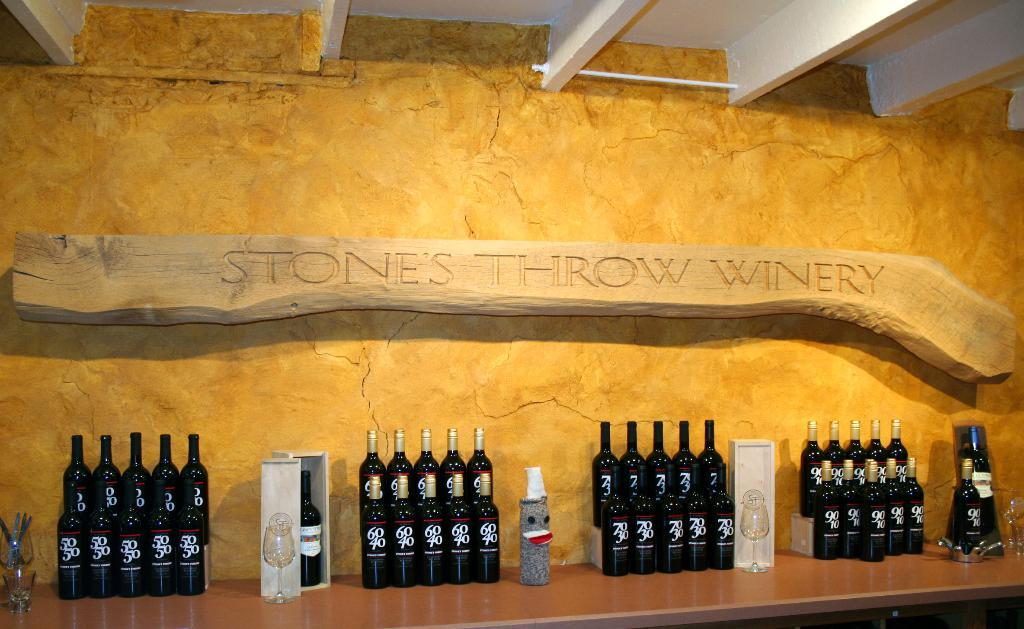<image>
Give a short and clear explanation of the subsequent image. display of wines on a table under a sign reading Stone's Throw Winery 